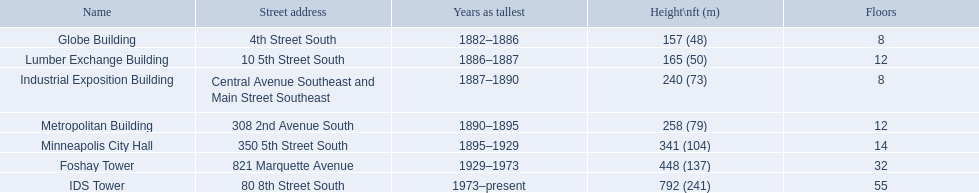What is the number of floors in the lumber exchange building? 12. Which additional building features 12 floors? Metropolitan Building. Which buildings in minneapolis have the greatest height? Globe Building, Lumber Exchange Building, Industrial Exposition Building, Metropolitan Building, Minneapolis City Hall, Foshay Tower, IDS Tower. Among them, are there any with 8 stories? Globe Building, Industrial Exposition Building. Furthermore, do any of these stand at 240 feet tall? Industrial Exposition Building. What is the count of floors in the globe building? 8. Which building features 14 floors? Minneapolis City Hall. Which building matches the lumber exchange building in terms of the number of floors? Metropolitan Building. 